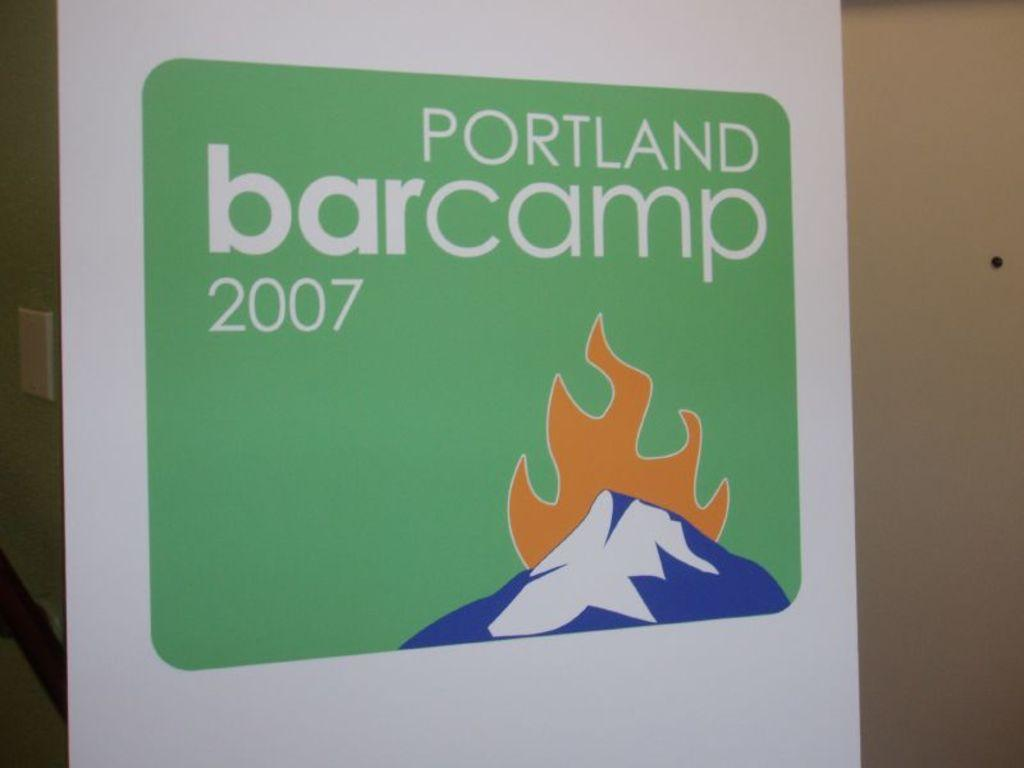What is the main object in the image? There is a banner in the image. What is featured on the banner? The banner contains a logo and some text. How many letters can be seen on the arm of the person holding the banner in the image? There is no person holding the banner in the image, and therefore no arm or letters on an arm can be observed. 